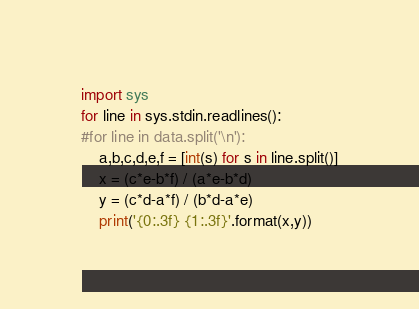Convert code to text. <code><loc_0><loc_0><loc_500><loc_500><_Python_>import sys
for line in sys.stdin.readlines():
#for line in data.split('\n'):
	a,b,c,d,e,f = [int(s) for s in line.split()]
	x = (c*e-b*f) / (a*e-b*d)
	y = (c*d-a*f) / (b*d-a*e)
	print('{0:.3f} {1:.3f}'.format(x,y))</code> 